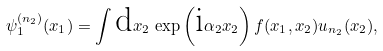<formula> <loc_0><loc_0><loc_500><loc_500>\psi _ { 1 } ^ { ( n _ { 2 } ) } ( x _ { 1 } ) = \int \text {d} x _ { 2 } \, \exp \left ( \text {i} \alpha _ { 2 } x _ { 2 } \right ) f ( x _ { 1 } , x _ { 2 } ) u _ { n _ { 2 } } ( x _ { 2 } ) ,</formula> 